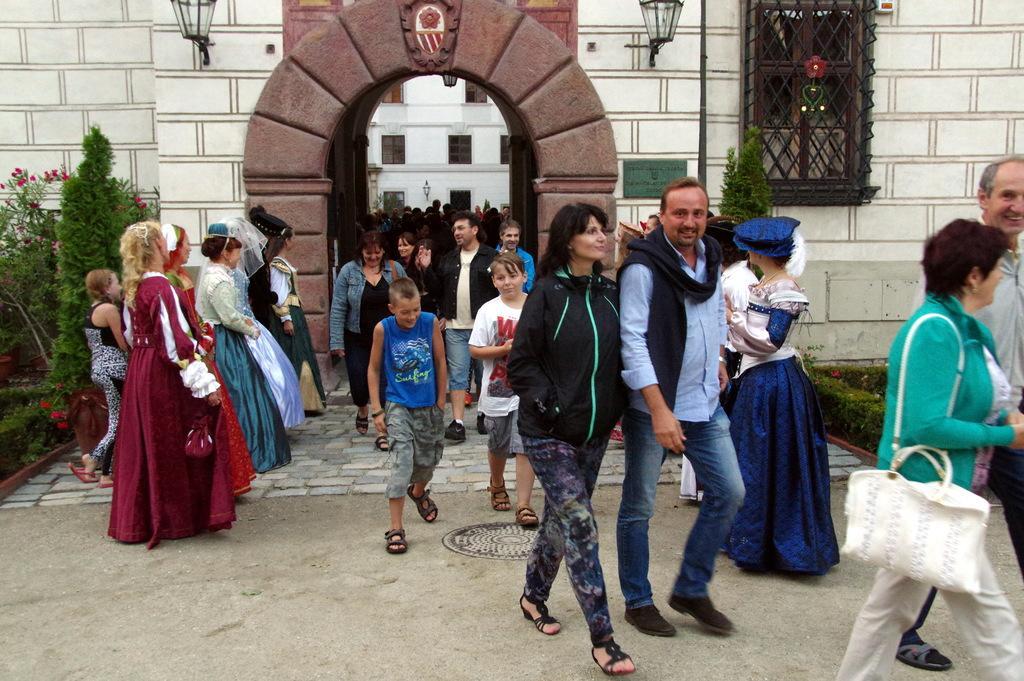Describe this image in one or two sentences. In this picture, we can see a few people and we can see the wall with some objects on it like lights, pole, net and we can also see an arch, plants, flowers, building with windows and we can see the ground. 